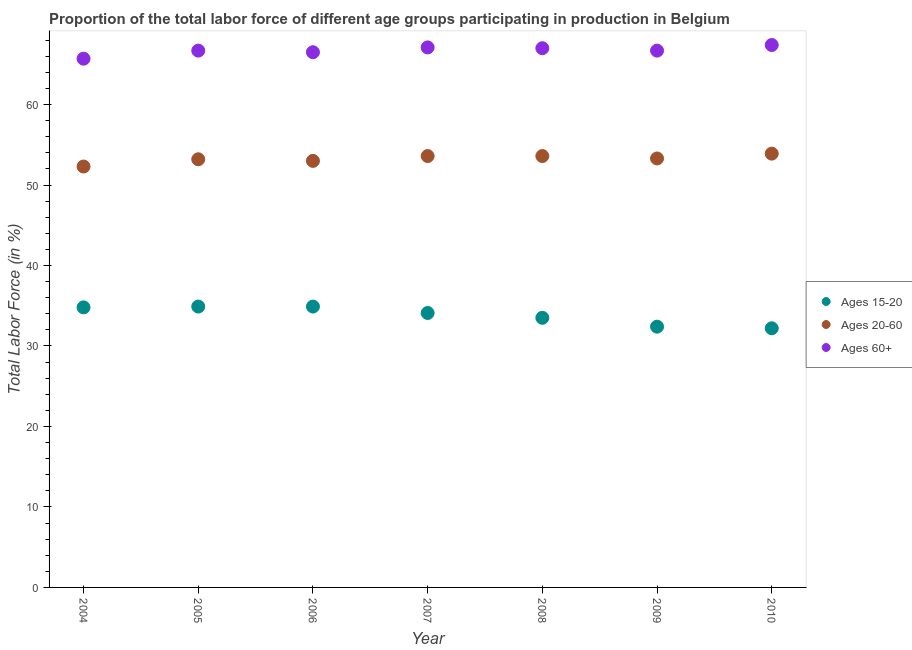What is the percentage of labor force within the age group 15-20 in 2009?
Your answer should be compact. 32.4. Across all years, what is the maximum percentage of labor force within the age group 20-60?
Offer a very short reply. 53.9. Across all years, what is the minimum percentage of labor force within the age group 20-60?
Your answer should be compact. 52.3. In which year was the percentage of labor force above age 60 minimum?
Make the answer very short. 2004. What is the total percentage of labor force above age 60 in the graph?
Ensure brevity in your answer.  467.1. What is the difference between the percentage of labor force within the age group 20-60 in 2006 and that in 2009?
Your response must be concise. -0.3. What is the difference between the percentage of labor force within the age group 20-60 in 2007 and the percentage of labor force above age 60 in 2004?
Your answer should be compact. -12.1. What is the average percentage of labor force above age 60 per year?
Give a very brief answer. 66.73. In the year 2010, what is the difference between the percentage of labor force within the age group 15-20 and percentage of labor force above age 60?
Give a very brief answer. -35.2. In how many years, is the percentage of labor force within the age group 15-20 greater than 20 %?
Make the answer very short. 7. What is the ratio of the percentage of labor force within the age group 15-20 in 2005 to that in 2008?
Offer a terse response. 1.04. Is the percentage of labor force within the age group 15-20 in 2006 less than that in 2007?
Give a very brief answer. No. What is the difference between the highest and the second highest percentage of labor force within the age group 20-60?
Give a very brief answer. 0.3. What is the difference between the highest and the lowest percentage of labor force within the age group 15-20?
Provide a succinct answer. 2.7. Is the sum of the percentage of labor force within the age group 20-60 in 2005 and 2007 greater than the maximum percentage of labor force above age 60 across all years?
Offer a very short reply. Yes. Is it the case that in every year, the sum of the percentage of labor force within the age group 15-20 and percentage of labor force within the age group 20-60 is greater than the percentage of labor force above age 60?
Give a very brief answer. Yes. Does the percentage of labor force within the age group 20-60 monotonically increase over the years?
Ensure brevity in your answer.  No. How many dotlines are there?
Your answer should be very brief. 3. Are the values on the major ticks of Y-axis written in scientific E-notation?
Make the answer very short. No. Does the graph contain grids?
Give a very brief answer. No. How are the legend labels stacked?
Your answer should be compact. Vertical. What is the title of the graph?
Give a very brief answer. Proportion of the total labor force of different age groups participating in production in Belgium. What is the Total Labor Force (in %) of Ages 15-20 in 2004?
Ensure brevity in your answer.  34.8. What is the Total Labor Force (in %) in Ages 20-60 in 2004?
Provide a succinct answer. 52.3. What is the Total Labor Force (in %) of Ages 60+ in 2004?
Give a very brief answer. 65.7. What is the Total Labor Force (in %) of Ages 15-20 in 2005?
Make the answer very short. 34.9. What is the Total Labor Force (in %) in Ages 20-60 in 2005?
Provide a short and direct response. 53.2. What is the Total Labor Force (in %) of Ages 60+ in 2005?
Your answer should be compact. 66.7. What is the Total Labor Force (in %) of Ages 15-20 in 2006?
Ensure brevity in your answer.  34.9. What is the Total Labor Force (in %) in Ages 60+ in 2006?
Offer a very short reply. 66.5. What is the Total Labor Force (in %) of Ages 15-20 in 2007?
Offer a terse response. 34.1. What is the Total Labor Force (in %) of Ages 20-60 in 2007?
Your response must be concise. 53.6. What is the Total Labor Force (in %) of Ages 60+ in 2007?
Provide a succinct answer. 67.1. What is the Total Labor Force (in %) of Ages 15-20 in 2008?
Your answer should be very brief. 33.5. What is the Total Labor Force (in %) in Ages 20-60 in 2008?
Provide a succinct answer. 53.6. What is the Total Labor Force (in %) in Ages 15-20 in 2009?
Offer a very short reply. 32.4. What is the Total Labor Force (in %) in Ages 20-60 in 2009?
Keep it short and to the point. 53.3. What is the Total Labor Force (in %) of Ages 60+ in 2009?
Your answer should be compact. 66.7. What is the Total Labor Force (in %) of Ages 15-20 in 2010?
Your answer should be compact. 32.2. What is the Total Labor Force (in %) in Ages 20-60 in 2010?
Keep it short and to the point. 53.9. What is the Total Labor Force (in %) in Ages 60+ in 2010?
Give a very brief answer. 67.4. Across all years, what is the maximum Total Labor Force (in %) in Ages 15-20?
Make the answer very short. 34.9. Across all years, what is the maximum Total Labor Force (in %) in Ages 20-60?
Your answer should be very brief. 53.9. Across all years, what is the maximum Total Labor Force (in %) in Ages 60+?
Give a very brief answer. 67.4. Across all years, what is the minimum Total Labor Force (in %) of Ages 15-20?
Make the answer very short. 32.2. Across all years, what is the minimum Total Labor Force (in %) in Ages 20-60?
Ensure brevity in your answer.  52.3. Across all years, what is the minimum Total Labor Force (in %) in Ages 60+?
Your response must be concise. 65.7. What is the total Total Labor Force (in %) of Ages 15-20 in the graph?
Provide a succinct answer. 236.8. What is the total Total Labor Force (in %) in Ages 20-60 in the graph?
Your answer should be compact. 372.9. What is the total Total Labor Force (in %) of Ages 60+ in the graph?
Offer a terse response. 467.1. What is the difference between the Total Labor Force (in %) in Ages 15-20 in 2004 and that in 2005?
Provide a short and direct response. -0.1. What is the difference between the Total Labor Force (in %) in Ages 20-60 in 2004 and that in 2006?
Keep it short and to the point. -0.7. What is the difference between the Total Labor Force (in %) of Ages 15-20 in 2004 and that in 2008?
Your response must be concise. 1.3. What is the difference between the Total Labor Force (in %) of Ages 20-60 in 2004 and that in 2008?
Offer a terse response. -1.3. What is the difference between the Total Labor Force (in %) of Ages 15-20 in 2004 and that in 2009?
Offer a very short reply. 2.4. What is the difference between the Total Labor Force (in %) in Ages 60+ in 2004 and that in 2009?
Give a very brief answer. -1. What is the difference between the Total Labor Force (in %) in Ages 15-20 in 2004 and that in 2010?
Make the answer very short. 2.6. What is the difference between the Total Labor Force (in %) of Ages 20-60 in 2004 and that in 2010?
Your response must be concise. -1.6. What is the difference between the Total Labor Force (in %) of Ages 15-20 in 2005 and that in 2006?
Ensure brevity in your answer.  0. What is the difference between the Total Labor Force (in %) in Ages 20-60 in 2005 and that in 2006?
Provide a succinct answer. 0.2. What is the difference between the Total Labor Force (in %) of Ages 60+ in 2005 and that in 2006?
Your answer should be compact. 0.2. What is the difference between the Total Labor Force (in %) of Ages 15-20 in 2005 and that in 2007?
Your answer should be compact. 0.8. What is the difference between the Total Labor Force (in %) in Ages 60+ in 2005 and that in 2007?
Offer a very short reply. -0.4. What is the difference between the Total Labor Force (in %) in Ages 60+ in 2005 and that in 2008?
Your response must be concise. -0.3. What is the difference between the Total Labor Force (in %) in Ages 20-60 in 2005 and that in 2009?
Your response must be concise. -0.1. What is the difference between the Total Labor Force (in %) in Ages 60+ in 2005 and that in 2009?
Give a very brief answer. 0. What is the difference between the Total Labor Force (in %) of Ages 15-20 in 2005 and that in 2010?
Your answer should be very brief. 2.7. What is the difference between the Total Labor Force (in %) of Ages 20-60 in 2005 and that in 2010?
Your answer should be compact. -0.7. What is the difference between the Total Labor Force (in %) of Ages 60+ in 2005 and that in 2010?
Your response must be concise. -0.7. What is the difference between the Total Labor Force (in %) of Ages 15-20 in 2006 and that in 2007?
Your answer should be very brief. 0.8. What is the difference between the Total Labor Force (in %) in Ages 60+ in 2006 and that in 2007?
Offer a terse response. -0.6. What is the difference between the Total Labor Force (in %) of Ages 15-20 in 2006 and that in 2008?
Give a very brief answer. 1.4. What is the difference between the Total Labor Force (in %) in Ages 20-60 in 2006 and that in 2009?
Provide a short and direct response. -0.3. What is the difference between the Total Labor Force (in %) of Ages 60+ in 2006 and that in 2010?
Give a very brief answer. -0.9. What is the difference between the Total Labor Force (in %) of Ages 20-60 in 2007 and that in 2008?
Your response must be concise. 0. What is the difference between the Total Labor Force (in %) of Ages 60+ in 2007 and that in 2009?
Offer a very short reply. 0.4. What is the difference between the Total Labor Force (in %) of Ages 15-20 in 2007 and that in 2010?
Your answer should be very brief. 1.9. What is the difference between the Total Labor Force (in %) of Ages 20-60 in 2007 and that in 2010?
Your response must be concise. -0.3. What is the difference between the Total Labor Force (in %) of Ages 60+ in 2007 and that in 2010?
Your response must be concise. -0.3. What is the difference between the Total Labor Force (in %) in Ages 15-20 in 2008 and that in 2010?
Ensure brevity in your answer.  1.3. What is the difference between the Total Labor Force (in %) in Ages 60+ in 2008 and that in 2010?
Your answer should be very brief. -0.4. What is the difference between the Total Labor Force (in %) in Ages 20-60 in 2009 and that in 2010?
Offer a very short reply. -0.6. What is the difference between the Total Labor Force (in %) of Ages 15-20 in 2004 and the Total Labor Force (in %) of Ages 20-60 in 2005?
Provide a succinct answer. -18.4. What is the difference between the Total Labor Force (in %) in Ages 15-20 in 2004 and the Total Labor Force (in %) in Ages 60+ in 2005?
Provide a succinct answer. -31.9. What is the difference between the Total Labor Force (in %) in Ages 20-60 in 2004 and the Total Labor Force (in %) in Ages 60+ in 2005?
Make the answer very short. -14.4. What is the difference between the Total Labor Force (in %) in Ages 15-20 in 2004 and the Total Labor Force (in %) in Ages 20-60 in 2006?
Give a very brief answer. -18.2. What is the difference between the Total Labor Force (in %) of Ages 15-20 in 2004 and the Total Labor Force (in %) of Ages 60+ in 2006?
Provide a succinct answer. -31.7. What is the difference between the Total Labor Force (in %) in Ages 20-60 in 2004 and the Total Labor Force (in %) in Ages 60+ in 2006?
Provide a short and direct response. -14.2. What is the difference between the Total Labor Force (in %) of Ages 15-20 in 2004 and the Total Labor Force (in %) of Ages 20-60 in 2007?
Offer a terse response. -18.8. What is the difference between the Total Labor Force (in %) of Ages 15-20 in 2004 and the Total Labor Force (in %) of Ages 60+ in 2007?
Offer a terse response. -32.3. What is the difference between the Total Labor Force (in %) of Ages 20-60 in 2004 and the Total Labor Force (in %) of Ages 60+ in 2007?
Provide a succinct answer. -14.8. What is the difference between the Total Labor Force (in %) in Ages 15-20 in 2004 and the Total Labor Force (in %) in Ages 20-60 in 2008?
Offer a terse response. -18.8. What is the difference between the Total Labor Force (in %) in Ages 15-20 in 2004 and the Total Labor Force (in %) in Ages 60+ in 2008?
Keep it short and to the point. -32.2. What is the difference between the Total Labor Force (in %) in Ages 20-60 in 2004 and the Total Labor Force (in %) in Ages 60+ in 2008?
Make the answer very short. -14.7. What is the difference between the Total Labor Force (in %) in Ages 15-20 in 2004 and the Total Labor Force (in %) in Ages 20-60 in 2009?
Offer a very short reply. -18.5. What is the difference between the Total Labor Force (in %) of Ages 15-20 in 2004 and the Total Labor Force (in %) of Ages 60+ in 2009?
Provide a succinct answer. -31.9. What is the difference between the Total Labor Force (in %) in Ages 20-60 in 2004 and the Total Labor Force (in %) in Ages 60+ in 2009?
Offer a terse response. -14.4. What is the difference between the Total Labor Force (in %) of Ages 15-20 in 2004 and the Total Labor Force (in %) of Ages 20-60 in 2010?
Give a very brief answer. -19.1. What is the difference between the Total Labor Force (in %) of Ages 15-20 in 2004 and the Total Labor Force (in %) of Ages 60+ in 2010?
Your response must be concise. -32.6. What is the difference between the Total Labor Force (in %) in Ages 20-60 in 2004 and the Total Labor Force (in %) in Ages 60+ in 2010?
Make the answer very short. -15.1. What is the difference between the Total Labor Force (in %) of Ages 15-20 in 2005 and the Total Labor Force (in %) of Ages 20-60 in 2006?
Your answer should be very brief. -18.1. What is the difference between the Total Labor Force (in %) in Ages 15-20 in 2005 and the Total Labor Force (in %) in Ages 60+ in 2006?
Provide a succinct answer. -31.6. What is the difference between the Total Labor Force (in %) in Ages 20-60 in 2005 and the Total Labor Force (in %) in Ages 60+ in 2006?
Offer a very short reply. -13.3. What is the difference between the Total Labor Force (in %) of Ages 15-20 in 2005 and the Total Labor Force (in %) of Ages 20-60 in 2007?
Offer a terse response. -18.7. What is the difference between the Total Labor Force (in %) in Ages 15-20 in 2005 and the Total Labor Force (in %) in Ages 60+ in 2007?
Keep it short and to the point. -32.2. What is the difference between the Total Labor Force (in %) of Ages 20-60 in 2005 and the Total Labor Force (in %) of Ages 60+ in 2007?
Provide a succinct answer. -13.9. What is the difference between the Total Labor Force (in %) of Ages 15-20 in 2005 and the Total Labor Force (in %) of Ages 20-60 in 2008?
Give a very brief answer. -18.7. What is the difference between the Total Labor Force (in %) in Ages 15-20 in 2005 and the Total Labor Force (in %) in Ages 60+ in 2008?
Ensure brevity in your answer.  -32.1. What is the difference between the Total Labor Force (in %) in Ages 20-60 in 2005 and the Total Labor Force (in %) in Ages 60+ in 2008?
Offer a very short reply. -13.8. What is the difference between the Total Labor Force (in %) in Ages 15-20 in 2005 and the Total Labor Force (in %) in Ages 20-60 in 2009?
Make the answer very short. -18.4. What is the difference between the Total Labor Force (in %) in Ages 15-20 in 2005 and the Total Labor Force (in %) in Ages 60+ in 2009?
Offer a terse response. -31.8. What is the difference between the Total Labor Force (in %) of Ages 20-60 in 2005 and the Total Labor Force (in %) of Ages 60+ in 2009?
Make the answer very short. -13.5. What is the difference between the Total Labor Force (in %) of Ages 15-20 in 2005 and the Total Labor Force (in %) of Ages 60+ in 2010?
Provide a short and direct response. -32.5. What is the difference between the Total Labor Force (in %) of Ages 20-60 in 2005 and the Total Labor Force (in %) of Ages 60+ in 2010?
Offer a very short reply. -14.2. What is the difference between the Total Labor Force (in %) of Ages 15-20 in 2006 and the Total Labor Force (in %) of Ages 20-60 in 2007?
Provide a short and direct response. -18.7. What is the difference between the Total Labor Force (in %) of Ages 15-20 in 2006 and the Total Labor Force (in %) of Ages 60+ in 2007?
Provide a short and direct response. -32.2. What is the difference between the Total Labor Force (in %) in Ages 20-60 in 2006 and the Total Labor Force (in %) in Ages 60+ in 2007?
Your response must be concise. -14.1. What is the difference between the Total Labor Force (in %) in Ages 15-20 in 2006 and the Total Labor Force (in %) in Ages 20-60 in 2008?
Your answer should be very brief. -18.7. What is the difference between the Total Labor Force (in %) of Ages 15-20 in 2006 and the Total Labor Force (in %) of Ages 60+ in 2008?
Provide a short and direct response. -32.1. What is the difference between the Total Labor Force (in %) of Ages 15-20 in 2006 and the Total Labor Force (in %) of Ages 20-60 in 2009?
Make the answer very short. -18.4. What is the difference between the Total Labor Force (in %) in Ages 15-20 in 2006 and the Total Labor Force (in %) in Ages 60+ in 2009?
Provide a short and direct response. -31.8. What is the difference between the Total Labor Force (in %) in Ages 20-60 in 2006 and the Total Labor Force (in %) in Ages 60+ in 2009?
Your response must be concise. -13.7. What is the difference between the Total Labor Force (in %) in Ages 15-20 in 2006 and the Total Labor Force (in %) in Ages 60+ in 2010?
Make the answer very short. -32.5. What is the difference between the Total Labor Force (in %) of Ages 20-60 in 2006 and the Total Labor Force (in %) of Ages 60+ in 2010?
Offer a very short reply. -14.4. What is the difference between the Total Labor Force (in %) of Ages 15-20 in 2007 and the Total Labor Force (in %) of Ages 20-60 in 2008?
Ensure brevity in your answer.  -19.5. What is the difference between the Total Labor Force (in %) in Ages 15-20 in 2007 and the Total Labor Force (in %) in Ages 60+ in 2008?
Provide a succinct answer. -32.9. What is the difference between the Total Labor Force (in %) in Ages 20-60 in 2007 and the Total Labor Force (in %) in Ages 60+ in 2008?
Provide a short and direct response. -13.4. What is the difference between the Total Labor Force (in %) of Ages 15-20 in 2007 and the Total Labor Force (in %) of Ages 20-60 in 2009?
Your answer should be very brief. -19.2. What is the difference between the Total Labor Force (in %) in Ages 15-20 in 2007 and the Total Labor Force (in %) in Ages 60+ in 2009?
Provide a succinct answer. -32.6. What is the difference between the Total Labor Force (in %) of Ages 20-60 in 2007 and the Total Labor Force (in %) of Ages 60+ in 2009?
Give a very brief answer. -13.1. What is the difference between the Total Labor Force (in %) in Ages 15-20 in 2007 and the Total Labor Force (in %) in Ages 20-60 in 2010?
Give a very brief answer. -19.8. What is the difference between the Total Labor Force (in %) of Ages 15-20 in 2007 and the Total Labor Force (in %) of Ages 60+ in 2010?
Your answer should be compact. -33.3. What is the difference between the Total Labor Force (in %) in Ages 20-60 in 2007 and the Total Labor Force (in %) in Ages 60+ in 2010?
Your answer should be very brief. -13.8. What is the difference between the Total Labor Force (in %) of Ages 15-20 in 2008 and the Total Labor Force (in %) of Ages 20-60 in 2009?
Offer a terse response. -19.8. What is the difference between the Total Labor Force (in %) of Ages 15-20 in 2008 and the Total Labor Force (in %) of Ages 60+ in 2009?
Keep it short and to the point. -33.2. What is the difference between the Total Labor Force (in %) of Ages 15-20 in 2008 and the Total Labor Force (in %) of Ages 20-60 in 2010?
Give a very brief answer. -20.4. What is the difference between the Total Labor Force (in %) of Ages 15-20 in 2008 and the Total Labor Force (in %) of Ages 60+ in 2010?
Provide a short and direct response. -33.9. What is the difference between the Total Labor Force (in %) of Ages 20-60 in 2008 and the Total Labor Force (in %) of Ages 60+ in 2010?
Ensure brevity in your answer.  -13.8. What is the difference between the Total Labor Force (in %) in Ages 15-20 in 2009 and the Total Labor Force (in %) in Ages 20-60 in 2010?
Provide a short and direct response. -21.5. What is the difference between the Total Labor Force (in %) in Ages 15-20 in 2009 and the Total Labor Force (in %) in Ages 60+ in 2010?
Your answer should be very brief. -35. What is the difference between the Total Labor Force (in %) in Ages 20-60 in 2009 and the Total Labor Force (in %) in Ages 60+ in 2010?
Keep it short and to the point. -14.1. What is the average Total Labor Force (in %) of Ages 15-20 per year?
Ensure brevity in your answer.  33.83. What is the average Total Labor Force (in %) of Ages 20-60 per year?
Your response must be concise. 53.27. What is the average Total Labor Force (in %) in Ages 60+ per year?
Make the answer very short. 66.73. In the year 2004, what is the difference between the Total Labor Force (in %) of Ages 15-20 and Total Labor Force (in %) of Ages 20-60?
Offer a terse response. -17.5. In the year 2004, what is the difference between the Total Labor Force (in %) in Ages 15-20 and Total Labor Force (in %) in Ages 60+?
Provide a short and direct response. -30.9. In the year 2004, what is the difference between the Total Labor Force (in %) of Ages 20-60 and Total Labor Force (in %) of Ages 60+?
Offer a very short reply. -13.4. In the year 2005, what is the difference between the Total Labor Force (in %) of Ages 15-20 and Total Labor Force (in %) of Ages 20-60?
Provide a short and direct response. -18.3. In the year 2005, what is the difference between the Total Labor Force (in %) of Ages 15-20 and Total Labor Force (in %) of Ages 60+?
Offer a very short reply. -31.8. In the year 2006, what is the difference between the Total Labor Force (in %) in Ages 15-20 and Total Labor Force (in %) in Ages 20-60?
Keep it short and to the point. -18.1. In the year 2006, what is the difference between the Total Labor Force (in %) of Ages 15-20 and Total Labor Force (in %) of Ages 60+?
Offer a very short reply. -31.6. In the year 2006, what is the difference between the Total Labor Force (in %) of Ages 20-60 and Total Labor Force (in %) of Ages 60+?
Keep it short and to the point. -13.5. In the year 2007, what is the difference between the Total Labor Force (in %) of Ages 15-20 and Total Labor Force (in %) of Ages 20-60?
Your answer should be very brief. -19.5. In the year 2007, what is the difference between the Total Labor Force (in %) of Ages 15-20 and Total Labor Force (in %) of Ages 60+?
Make the answer very short. -33. In the year 2008, what is the difference between the Total Labor Force (in %) in Ages 15-20 and Total Labor Force (in %) in Ages 20-60?
Give a very brief answer. -20.1. In the year 2008, what is the difference between the Total Labor Force (in %) of Ages 15-20 and Total Labor Force (in %) of Ages 60+?
Your response must be concise. -33.5. In the year 2009, what is the difference between the Total Labor Force (in %) in Ages 15-20 and Total Labor Force (in %) in Ages 20-60?
Give a very brief answer. -20.9. In the year 2009, what is the difference between the Total Labor Force (in %) of Ages 15-20 and Total Labor Force (in %) of Ages 60+?
Offer a terse response. -34.3. In the year 2010, what is the difference between the Total Labor Force (in %) of Ages 15-20 and Total Labor Force (in %) of Ages 20-60?
Your response must be concise. -21.7. In the year 2010, what is the difference between the Total Labor Force (in %) in Ages 15-20 and Total Labor Force (in %) in Ages 60+?
Your answer should be compact. -35.2. What is the ratio of the Total Labor Force (in %) of Ages 20-60 in 2004 to that in 2005?
Offer a very short reply. 0.98. What is the ratio of the Total Labor Force (in %) in Ages 20-60 in 2004 to that in 2006?
Offer a terse response. 0.99. What is the ratio of the Total Labor Force (in %) of Ages 60+ in 2004 to that in 2006?
Give a very brief answer. 0.99. What is the ratio of the Total Labor Force (in %) of Ages 15-20 in 2004 to that in 2007?
Your answer should be compact. 1.02. What is the ratio of the Total Labor Force (in %) in Ages 20-60 in 2004 to that in 2007?
Your answer should be compact. 0.98. What is the ratio of the Total Labor Force (in %) in Ages 60+ in 2004 to that in 2007?
Your answer should be very brief. 0.98. What is the ratio of the Total Labor Force (in %) in Ages 15-20 in 2004 to that in 2008?
Give a very brief answer. 1.04. What is the ratio of the Total Labor Force (in %) of Ages 20-60 in 2004 to that in 2008?
Keep it short and to the point. 0.98. What is the ratio of the Total Labor Force (in %) of Ages 60+ in 2004 to that in 2008?
Provide a succinct answer. 0.98. What is the ratio of the Total Labor Force (in %) in Ages 15-20 in 2004 to that in 2009?
Your response must be concise. 1.07. What is the ratio of the Total Labor Force (in %) of Ages 20-60 in 2004 to that in 2009?
Keep it short and to the point. 0.98. What is the ratio of the Total Labor Force (in %) of Ages 60+ in 2004 to that in 2009?
Make the answer very short. 0.98. What is the ratio of the Total Labor Force (in %) of Ages 15-20 in 2004 to that in 2010?
Your answer should be very brief. 1.08. What is the ratio of the Total Labor Force (in %) of Ages 20-60 in 2004 to that in 2010?
Offer a very short reply. 0.97. What is the ratio of the Total Labor Force (in %) of Ages 60+ in 2004 to that in 2010?
Make the answer very short. 0.97. What is the ratio of the Total Labor Force (in %) in Ages 20-60 in 2005 to that in 2006?
Provide a short and direct response. 1. What is the ratio of the Total Labor Force (in %) of Ages 15-20 in 2005 to that in 2007?
Ensure brevity in your answer.  1.02. What is the ratio of the Total Labor Force (in %) of Ages 20-60 in 2005 to that in 2007?
Your response must be concise. 0.99. What is the ratio of the Total Labor Force (in %) in Ages 15-20 in 2005 to that in 2008?
Your answer should be very brief. 1.04. What is the ratio of the Total Labor Force (in %) in Ages 20-60 in 2005 to that in 2008?
Your answer should be compact. 0.99. What is the ratio of the Total Labor Force (in %) of Ages 15-20 in 2005 to that in 2009?
Provide a short and direct response. 1.08. What is the ratio of the Total Labor Force (in %) of Ages 20-60 in 2005 to that in 2009?
Your response must be concise. 1. What is the ratio of the Total Labor Force (in %) in Ages 60+ in 2005 to that in 2009?
Offer a very short reply. 1. What is the ratio of the Total Labor Force (in %) of Ages 15-20 in 2005 to that in 2010?
Offer a terse response. 1.08. What is the ratio of the Total Labor Force (in %) of Ages 20-60 in 2005 to that in 2010?
Your answer should be compact. 0.99. What is the ratio of the Total Labor Force (in %) in Ages 15-20 in 2006 to that in 2007?
Your response must be concise. 1.02. What is the ratio of the Total Labor Force (in %) of Ages 60+ in 2006 to that in 2007?
Keep it short and to the point. 0.99. What is the ratio of the Total Labor Force (in %) of Ages 15-20 in 2006 to that in 2008?
Make the answer very short. 1.04. What is the ratio of the Total Labor Force (in %) in Ages 15-20 in 2006 to that in 2009?
Ensure brevity in your answer.  1.08. What is the ratio of the Total Labor Force (in %) of Ages 60+ in 2006 to that in 2009?
Provide a succinct answer. 1. What is the ratio of the Total Labor Force (in %) of Ages 15-20 in 2006 to that in 2010?
Keep it short and to the point. 1.08. What is the ratio of the Total Labor Force (in %) of Ages 20-60 in 2006 to that in 2010?
Provide a short and direct response. 0.98. What is the ratio of the Total Labor Force (in %) in Ages 60+ in 2006 to that in 2010?
Make the answer very short. 0.99. What is the ratio of the Total Labor Force (in %) of Ages 15-20 in 2007 to that in 2008?
Keep it short and to the point. 1.02. What is the ratio of the Total Labor Force (in %) of Ages 20-60 in 2007 to that in 2008?
Your answer should be compact. 1. What is the ratio of the Total Labor Force (in %) of Ages 15-20 in 2007 to that in 2009?
Provide a short and direct response. 1.05. What is the ratio of the Total Labor Force (in %) in Ages 20-60 in 2007 to that in 2009?
Give a very brief answer. 1.01. What is the ratio of the Total Labor Force (in %) of Ages 60+ in 2007 to that in 2009?
Your answer should be compact. 1.01. What is the ratio of the Total Labor Force (in %) in Ages 15-20 in 2007 to that in 2010?
Offer a terse response. 1.06. What is the ratio of the Total Labor Force (in %) in Ages 15-20 in 2008 to that in 2009?
Your answer should be very brief. 1.03. What is the ratio of the Total Labor Force (in %) in Ages 20-60 in 2008 to that in 2009?
Your response must be concise. 1.01. What is the ratio of the Total Labor Force (in %) of Ages 60+ in 2008 to that in 2009?
Ensure brevity in your answer.  1. What is the ratio of the Total Labor Force (in %) in Ages 15-20 in 2008 to that in 2010?
Offer a very short reply. 1.04. What is the ratio of the Total Labor Force (in %) in Ages 20-60 in 2008 to that in 2010?
Make the answer very short. 0.99. What is the ratio of the Total Labor Force (in %) of Ages 60+ in 2008 to that in 2010?
Your response must be concise. 0.99. What is the ratio of the Total Labor Force (in %) of Ages 20-60 in 2009 to that in 2010?
Make the answer very short. 0.99. What is the difference between the highest and the second highest Total Labor Force (in %) in Ages 15-20?
Offer a terse response. 0. What is the difference between the highest and the second highest Total Labor Force (in %) in Ages 20-60?
Your response must be concise. 0.3. What is the difference between the highest and the lowest Total Labor Force (in %) in Ages 15-20?
Provide a succinct answer. 2.7. What is the difference between the highest and the lowest Total Labor Force (in %) of Ages 20-60?
Your response must be concise. 1.6. 